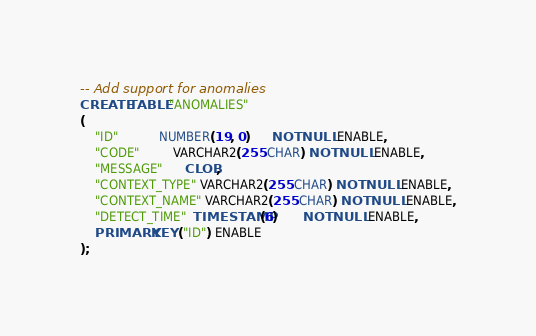<code> <loc_0><loc_0><loc_500><loc_500><_SQL_>-- Add support for anomalies
CREATE TABLE "ANOMALIES"
(
    "ID"           NUMBER(19, 0)      NOT NULL ENABLE,
    "CODE"         VARCHAR2(255 CHAR) NOT NULL ENABLE,
    "MESSAGE"      CLOB,
    "CONTEXT_TYPE" VARCHAR2(255 CHAR) NOT NULL ENABLE,
    "CONTEXT_NAME" VARCHAR2(255 CHAR) NOT NULL ENABLE,
    "DETECT_TIME"  TIMESTAMP(6)       NOT NULL ENABLE,
    PRIMARY KEY ("ID") ENABLE
);</code> 